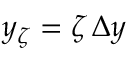Convert formula to latex. <formula><loc_0><loc_0><loc_500><loc_500>y _ { \zeta } = \zeta \, \Delta y</formula> 